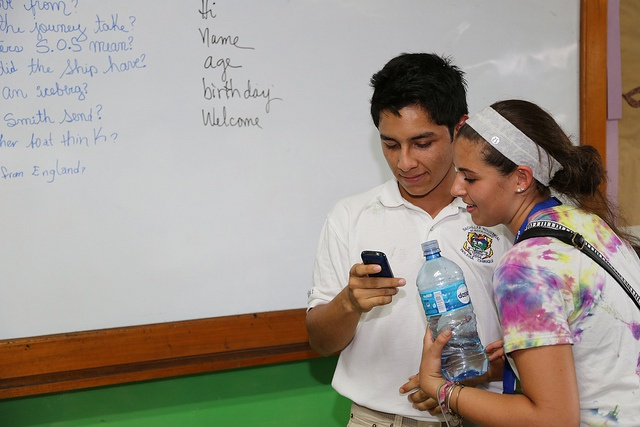Describe the objects in this image and their specific colors. I can see people in gray, salmon, darkgray, lightgray, and black tones, people in gray, lightgray, darkgray, and black tones, bottle in gray, darkgray, and lightgray tones, handbag in gray, black, darkgray, and lightgray tones, and cell phone in gray, black, lightgray, and darkgray tones in this image. 